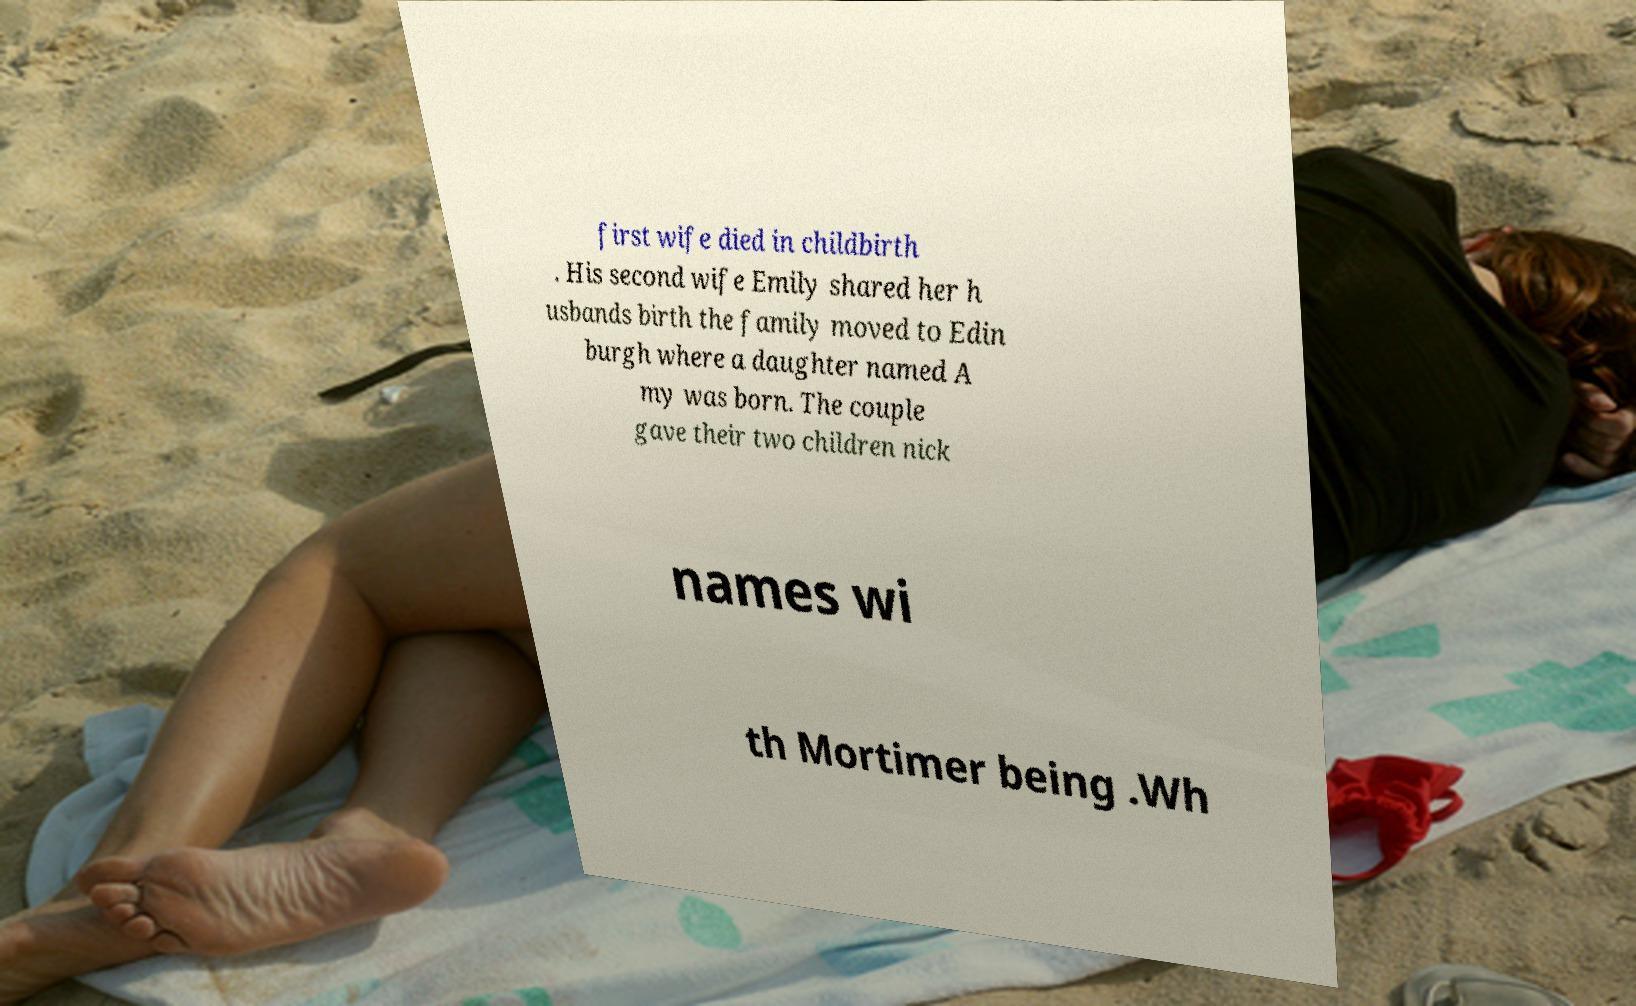I need the written content from this picture converted into text. Can you do that? first wife died in childbirth . His second wife Emily shared her h usbands birth the family moved to Edin burgh where a daughter named A my was born. The couple gave their two children nick names wi th Mortimer being .Wh 